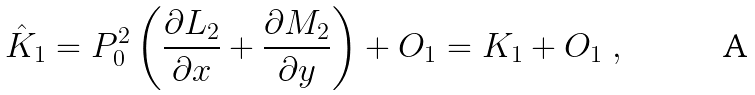<formula> <loc_0><loc_0><loc_500><loc_500>\hat { K } _ { 1 } = P _ { 0 } ^ { 2 } \left ( \frac { \partial L _ { 2 } } { \partial x } + \frac { \partial M _ { 2 } } { \partial y } \right ) + O _ { 1 } = K _ { 1 } + O _ { 1 } \ ,</formula> 